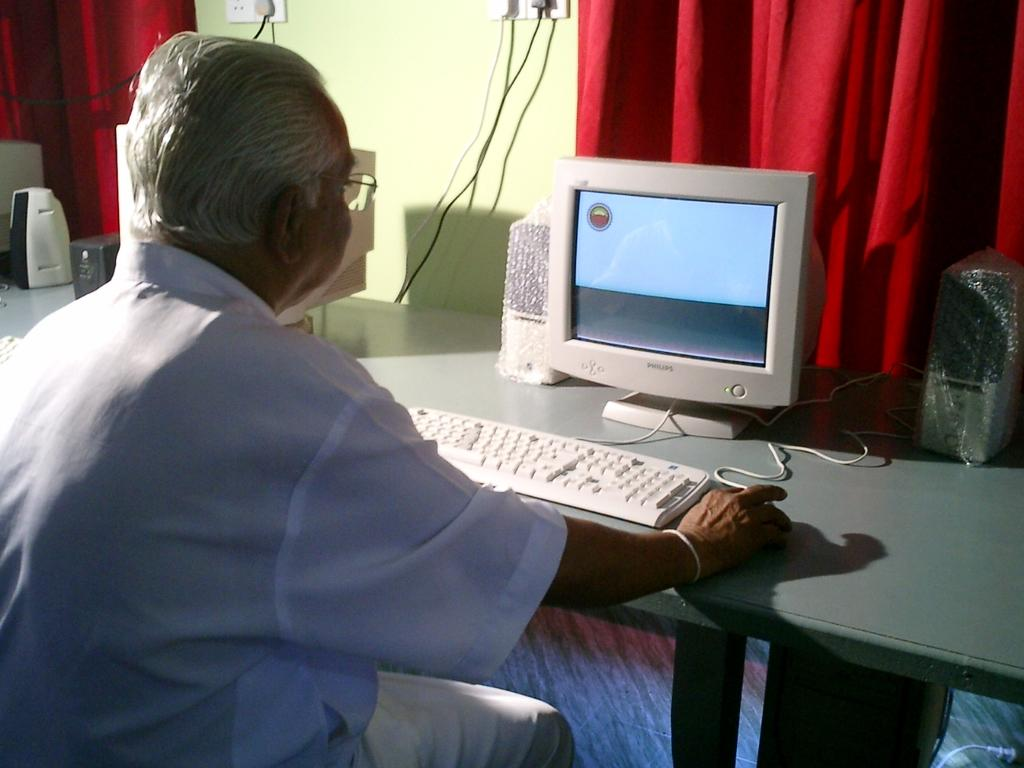What is the person in the image doing? The person is sitting in the image. What is in front of the person? The person is in front of a table. What can be seen on the table? There is a computer system and speakers on the table. What color are the curtains behind the computer system? The curtains are red. Where are the curtains located in relation to the wall? The curtains are beside a wall. What type of trousers is the person wearing in the image? The provided facts do not mention the type of trousers the person is wearing, so we cannot answer this question definitively. 